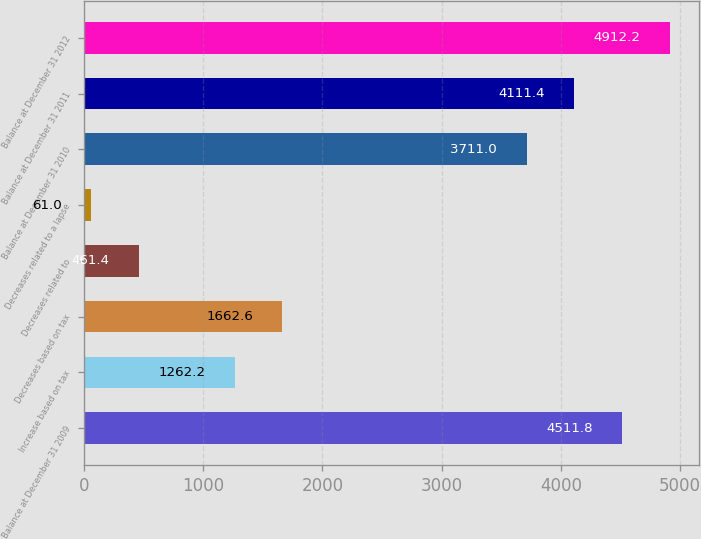Convert chart. <chart><loc_0><loc_0><loc_500><loc_500><bar_chart><fcel>Balance at December 31 2009<fcel>Increase based on tax<fcel>Decreases based on tax<fcel>Decreases related to<fcel>Decreases related to a lapse<fcel>Balance at December 31 2010<fcel>Balance at December 31 2011<fcel>Balance at December 31 2012<nl><fcel>4511.8<fcel>1262.2<fcel>1662.6<fcel>461.4<fcel>61<fcel>3711<fcel>4111.4<fcel>4912.2<nl></chart> 